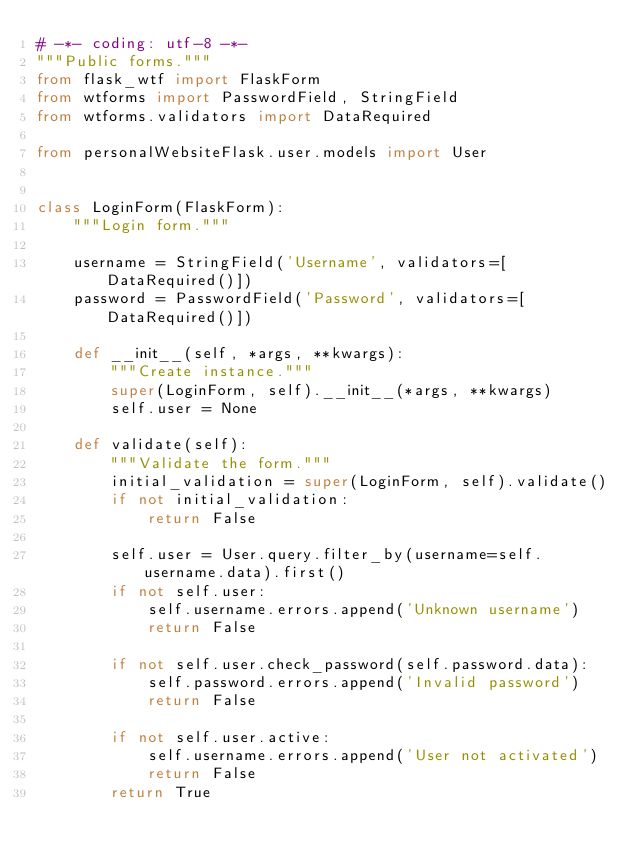Convert code to text. <code><loc_0><loc_0><loc_500><loc_500><_Python_># -*- coding: utf-8 -*-
"""Public forms."""
from flask_wtf import FlaskForm
from wtforms import PasswordField, StringField
from wtforms.validators import DataRequired

from personalWebsiteFlask.user.models import User


class LoginForm(FlaskForm):
    """Login form."""

    username = StringField('Username', validators=[DataRequired()])
    password = PasswordField('Password', validators=[DataRequired()])

    def __init__(self, *args, **kwargs):
        """Create instance."""
        super(LoginForm, self).__init__(*args, **kwargs)
        self.user = None

    def validate(self):
        """Validate the form."""
        initial_validation = super(LoginForm, self).validate()
        if not initial_validation:
            return False

        self.user = User.query.filter_by(username=self.username.data).first()
        if not self.user:
            self.username.errors.append('Unknown username')
            return False

        if not self.user.check_password(self.password.data):
            self.password.errors.append('Invalid password')
            return False

        if not self.user.active:
            self.username.errors.append('User not activated')
            return False
        return True
</code> 